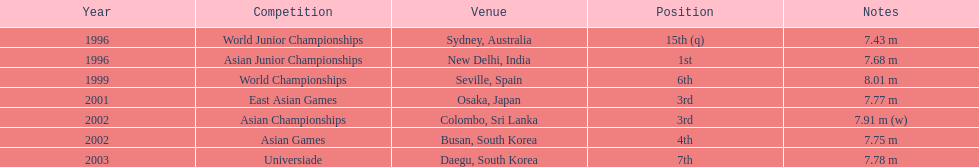How many total competitions were in south korea? 2. 